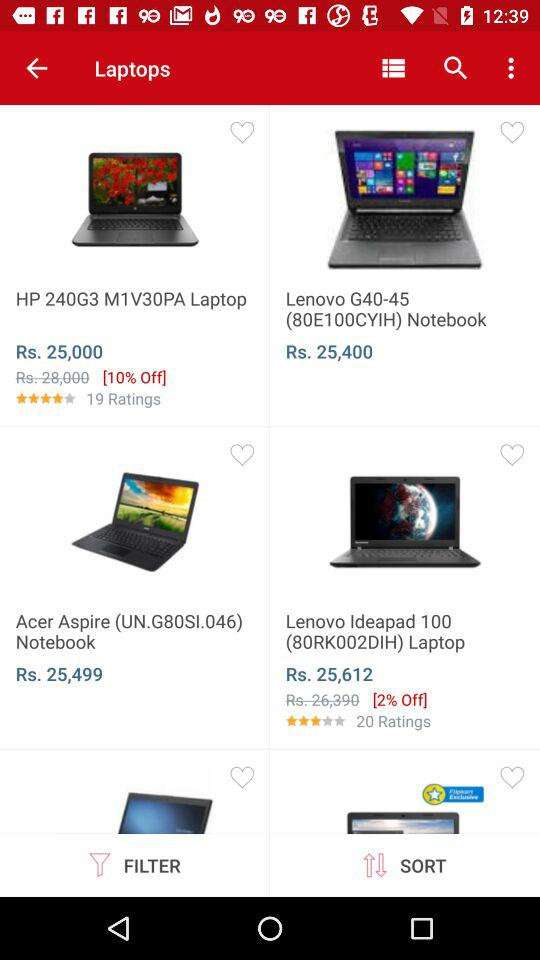What is the rating of "Lenovo Ideapad 100(80RK002DIH)" laptop? The rating is 3. 